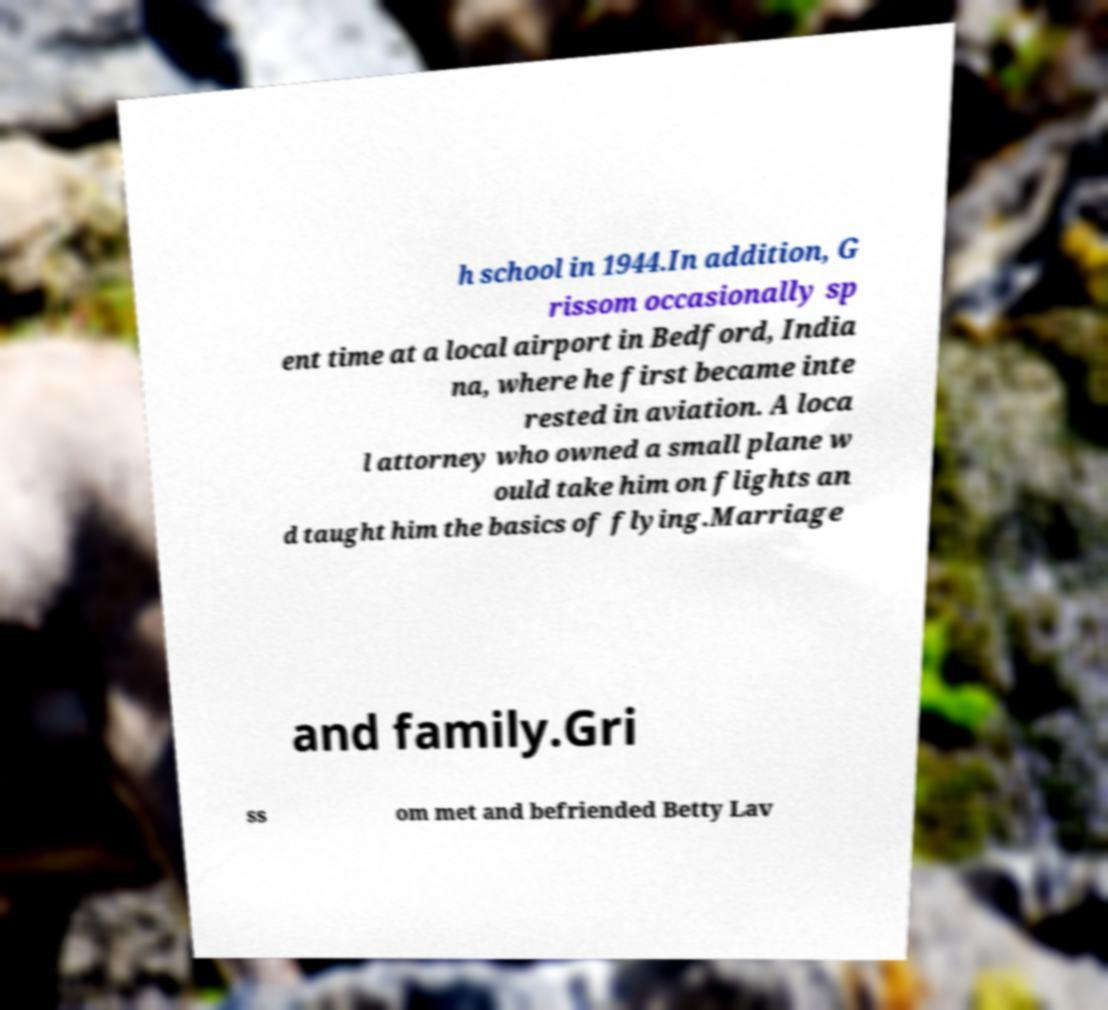For documentation purposes, I need the text within this image transcribed. Could you provide that? h school in 1944.In addition, G rissom occasionally sp ent time at a local airport in Bedford, India na, where he first became inte rested in aviation. A loca l attorney who owned a small plane w ould take him on flights an d taught him the basics of flying.Marriage and family.Gri ss om met and befriended Betty Lav 